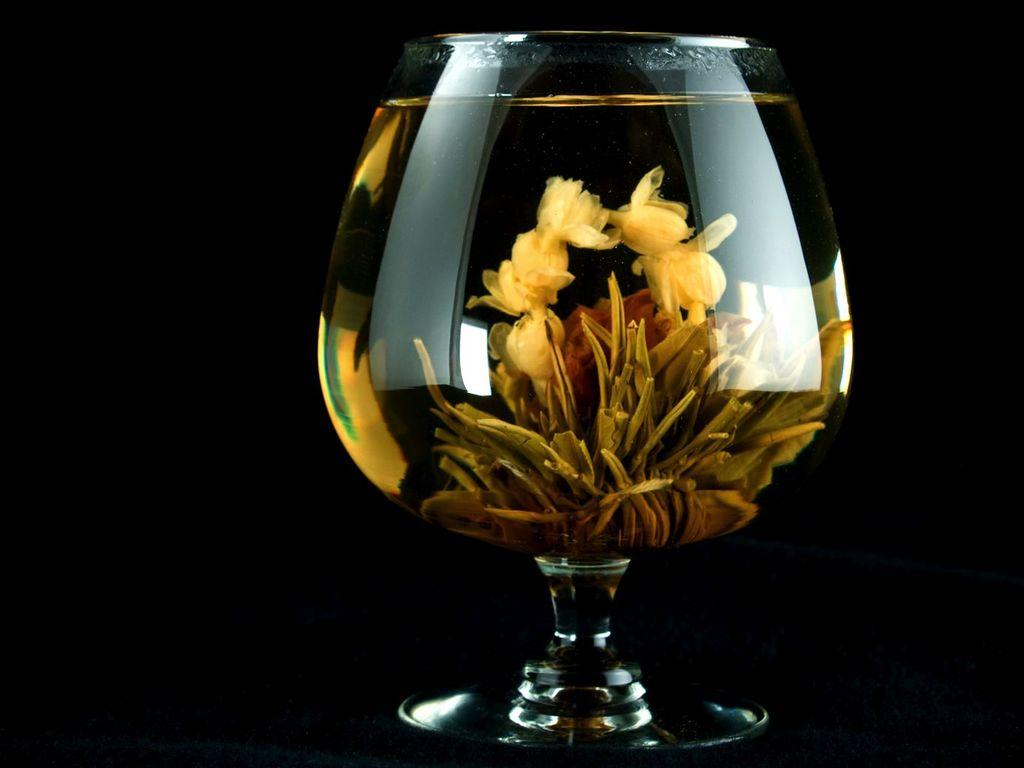What can be seen in the image? There is a glass in the image. What is inside the glass? There are objects in the glass. Can you describe the color of the objects in the glass? The objects in the glass are yellow and brown in color. How would you describe the overall lighting or color of the background in the image? The background of the image is dark. What type of government is depicted in the image? There is no depiction of a government in the image; it features a glass with yellow and brown objects. How many knees can be seen in the image? There are no knees visible in the image; it features a glass with yellow and brown objects against a dark background. 